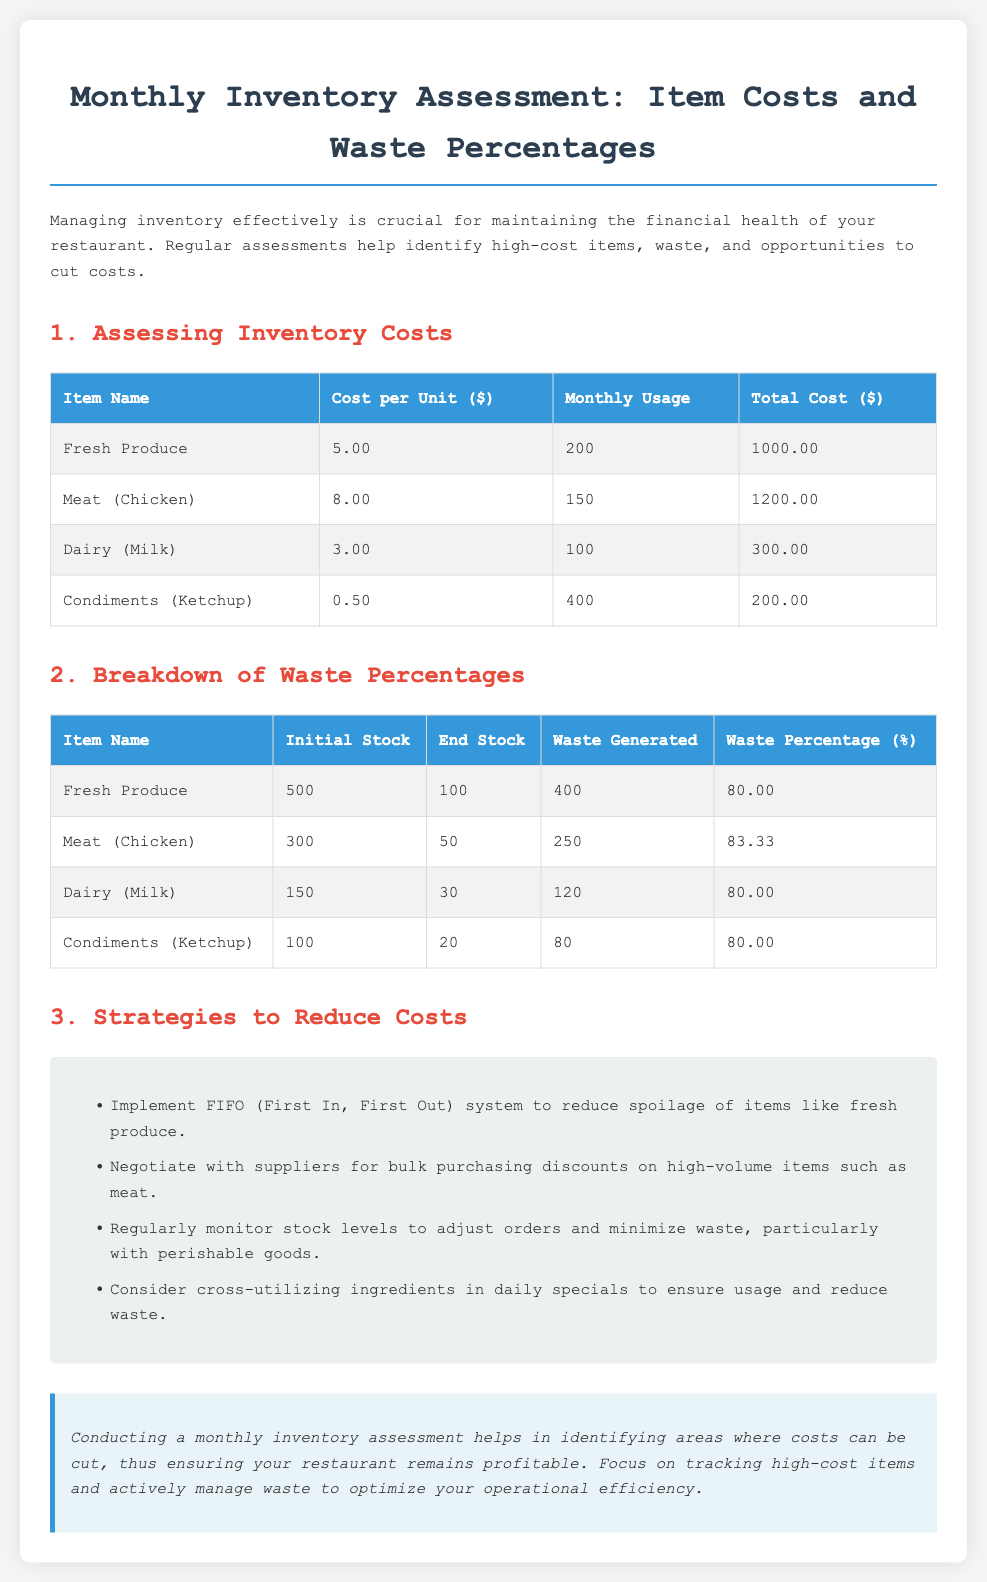What is the total cost for Fresh Produce? The total cost for Fresh Produce is calculated from its cost per unit multiplied by its monthly usage. Thus, $5.00 per unit multiplied by 200 units equals $1000.00.
Answer: $1000.00 What is the waste percentage for Meat (Chicken)? The waste percentage for Meat (Chicken) is provided in the document and is listed as 83.33%.
Answer: 83.33 Which item had the highest waste generated? The highest waste generated can be identified by comparing the waste figures. Fresh Produce generated 400 units of waste, which is the highest among the listed items.
Answer: Fresh Produce What strategy can help reduce spoilage of fresh produce? The document lists specific strategies, including implementing the FIFO (First In, First Out) system, which helps reduce spoilage.
Answer: FIFO system How much did the condiments (Ketchup) cost in total for the month? The total cost of condiments (Ketchup) is derived from multiplying its cost per unit by monthly usage, which is $0.50 per unit for 400 units, totaling $200.00.
Answer: $200.00 